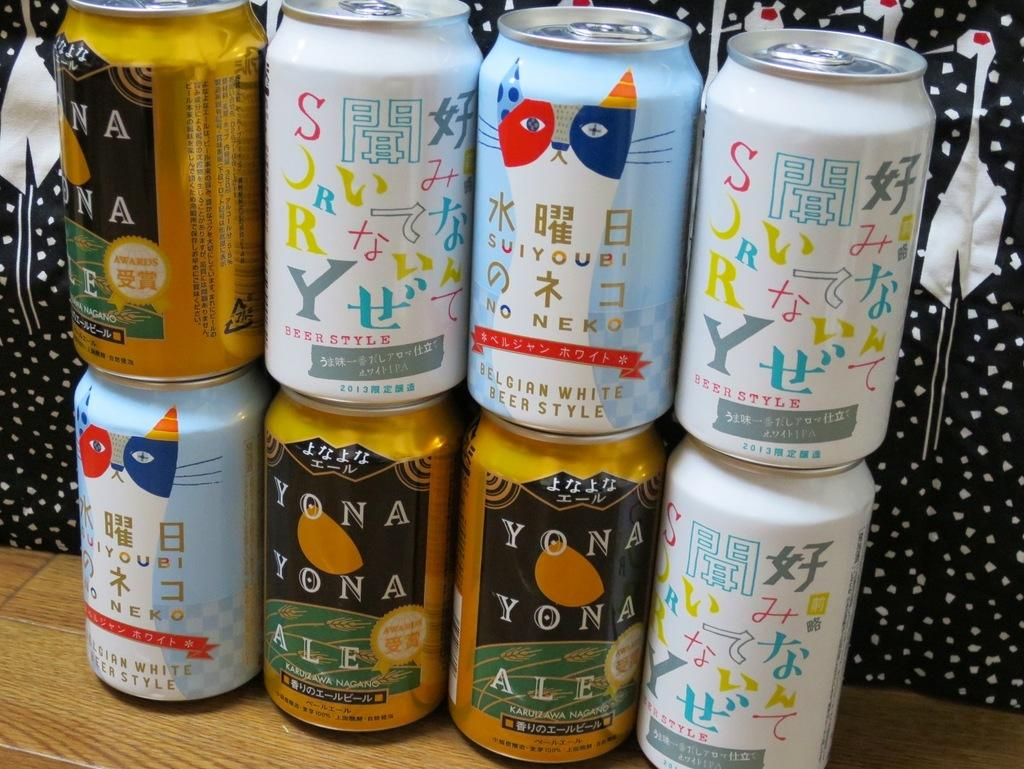<image>
Share a concise interpretation of the image provided. collection of Japanese soda including Yona Yona Ale 